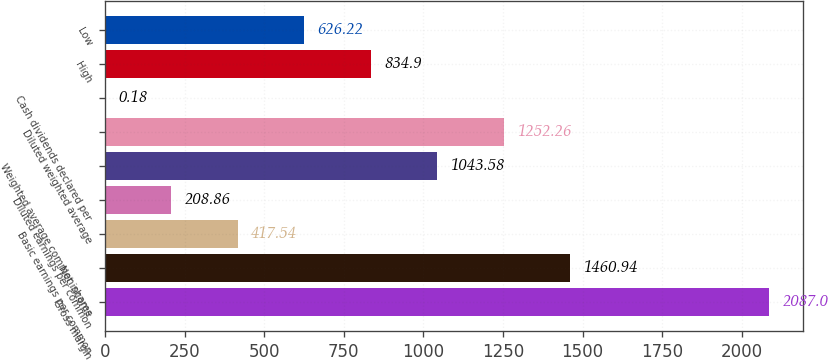<chart> <loc_0><loc_0><loc_500><loc_500><bar_chart><fcel>Gross margin<fcel>Net income<fcel>Basic earnings per common<fcel>Diluted earnings per common<fcel>Weighted average common shares<fcel>Diluted weighted average<fcel>Cash dividends declared per<fcel>High<fcel>Low<nl><fcel>2087<fcel>1460.94<fcel>417.54<fcel>208.86<fcel>1043.58<fcel>1252.26<fcel>0.18<fcel>834.9<fcel>626.22<nl></chart> 